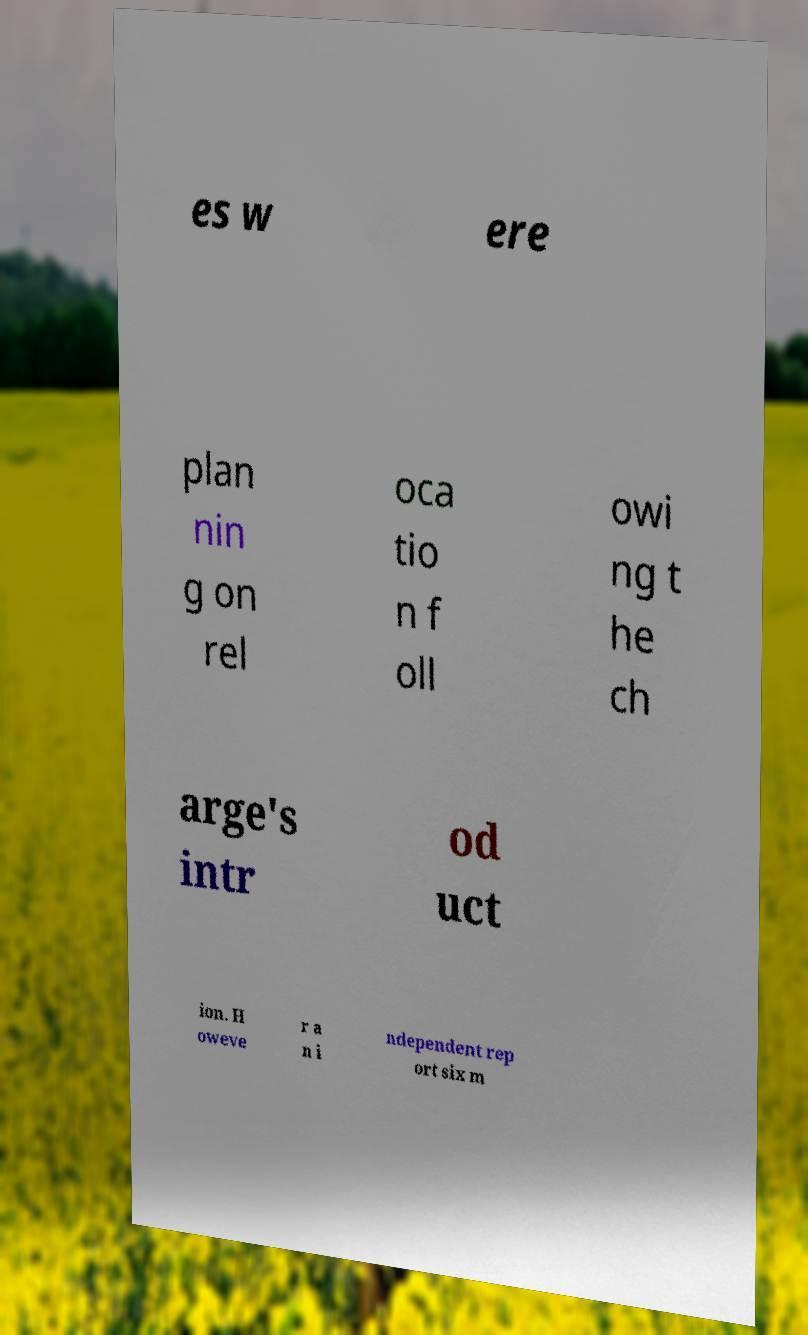Could you extract and type out the text from this image? es w ere plan nin g on rel oca tio n f oll owi ng t he ch arge's intr od uct ion. H oweve r a n i ndependent rep ort six m 